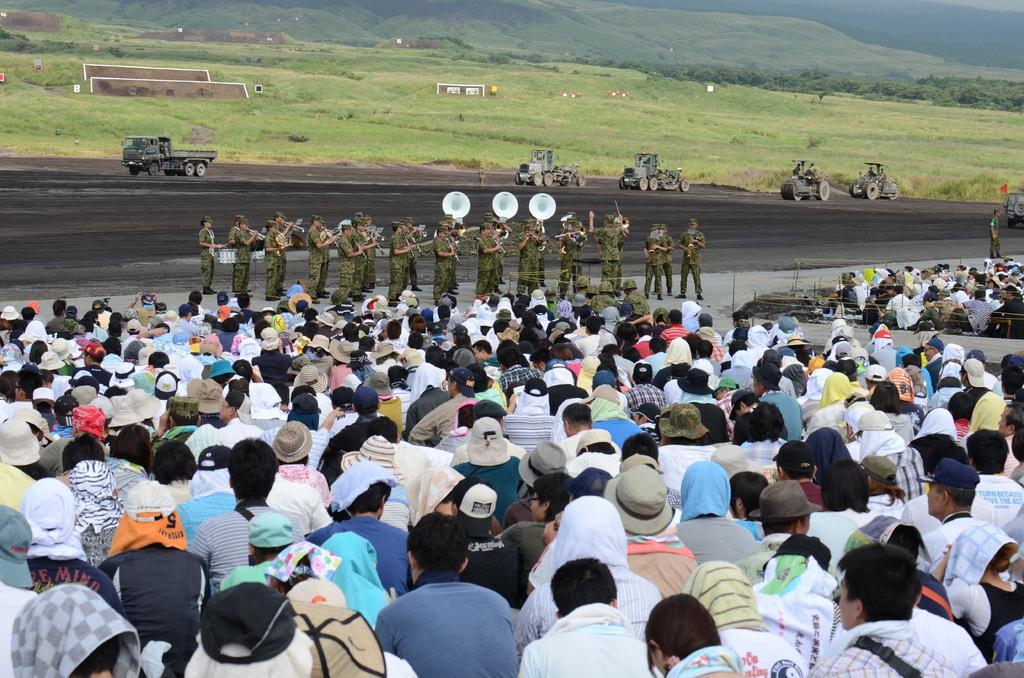Please provide a concise description of this image. In this image we can see a few people, among them some people are sitting and some people are standing and holding the objects, there are some vehicles on the ground, also we can see some trees, grass, mountains and some other objects. 